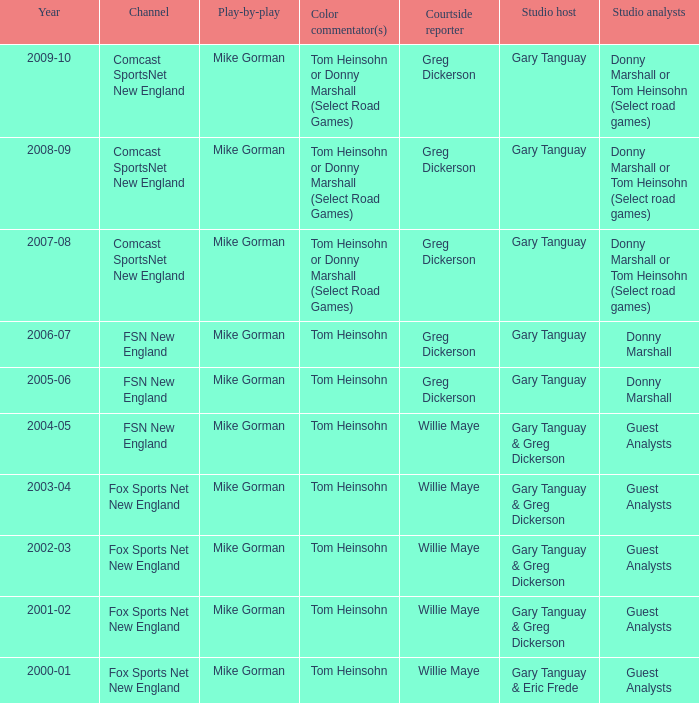Which Color commentator has a Channel of fsn new england, and a Year of 2004-05? Tom Heinsohn. 